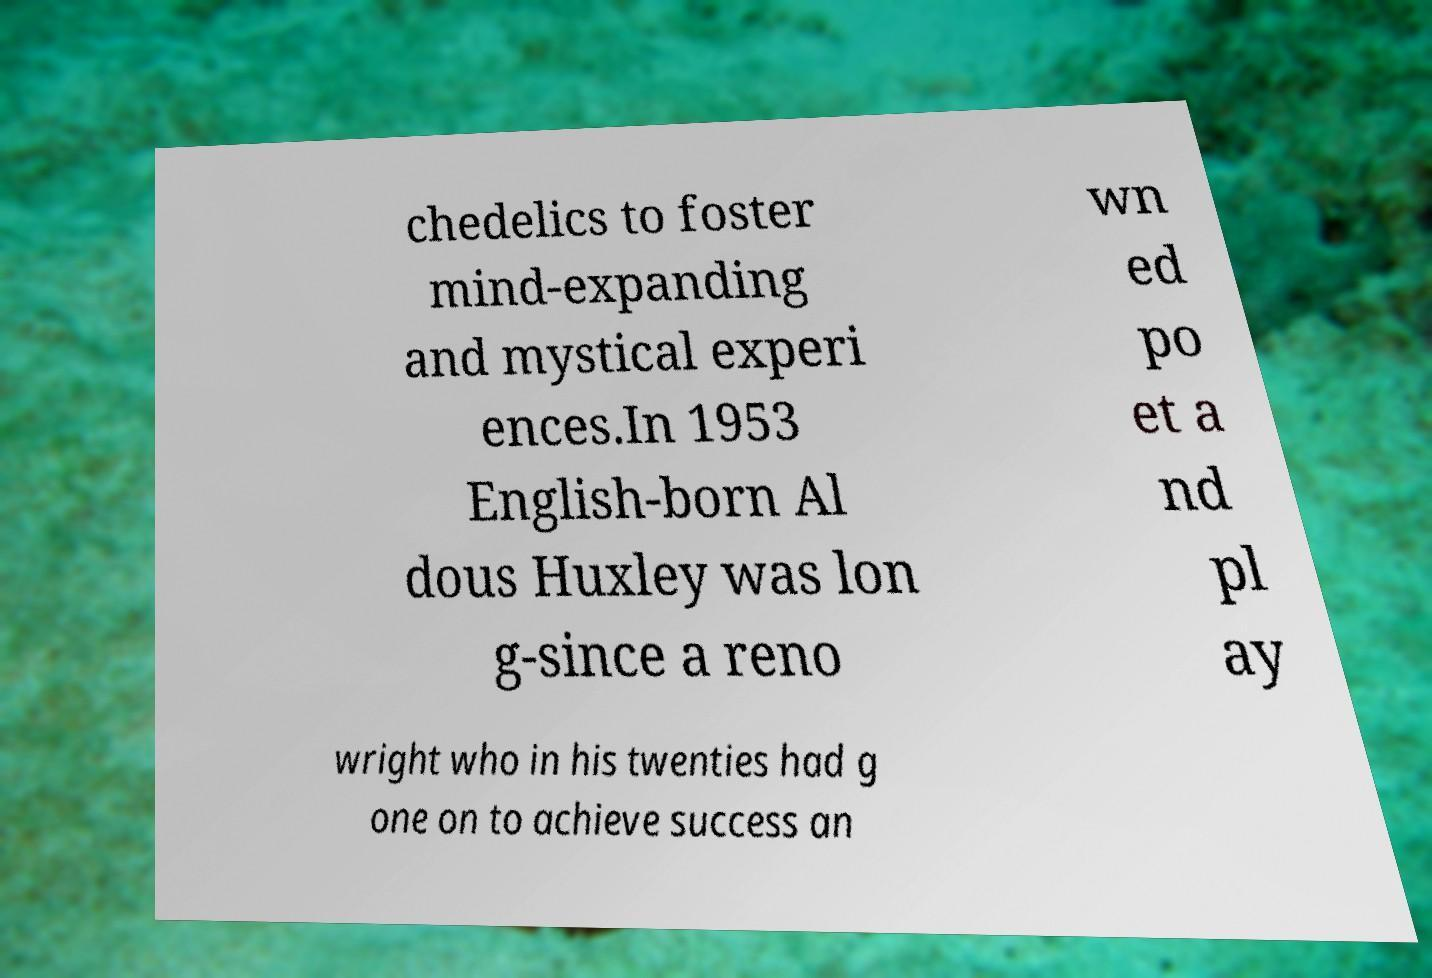Can you read and provide the text displayed in the image?This photo seems to have some interesting text. Can you extract and type it out for me? chedelics to foster mind-expanding and mystical experi ences.In 1953 English-born Al dous Huxley was lon g-since a reno wn ed po et a nd pl ay wright who in his twenties had g one on to achieve success an 